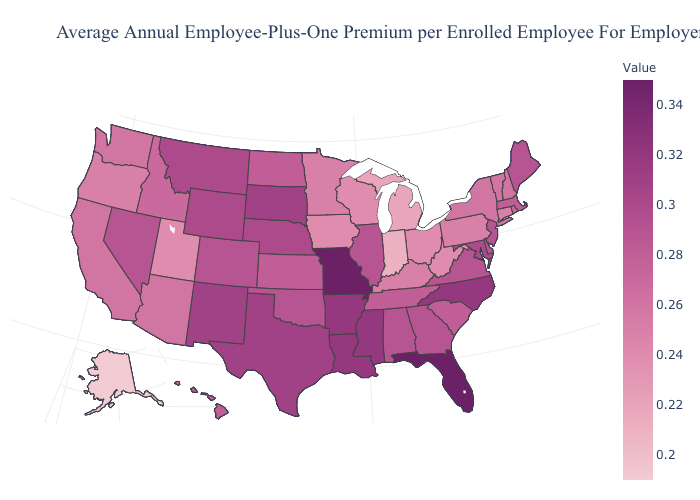Among the states that border Pennsylvania , which have the lowest value?
Answer briefly. Ohio, West Virginia. Which states have the lowest value in the Northeast?
Short answer required. Connecticut, Pennsylvania. Does South Dakota have the highest value in the MidWest?
Short answer required. No. Among the states that border Colorado , does Kansas have the lowest value?
Short answer required. No. Which states hav the highest value in the West?
Answer briefly. New Mexico. Does New Mexico have the highest value in the West?
Concise answer only. Yes. 